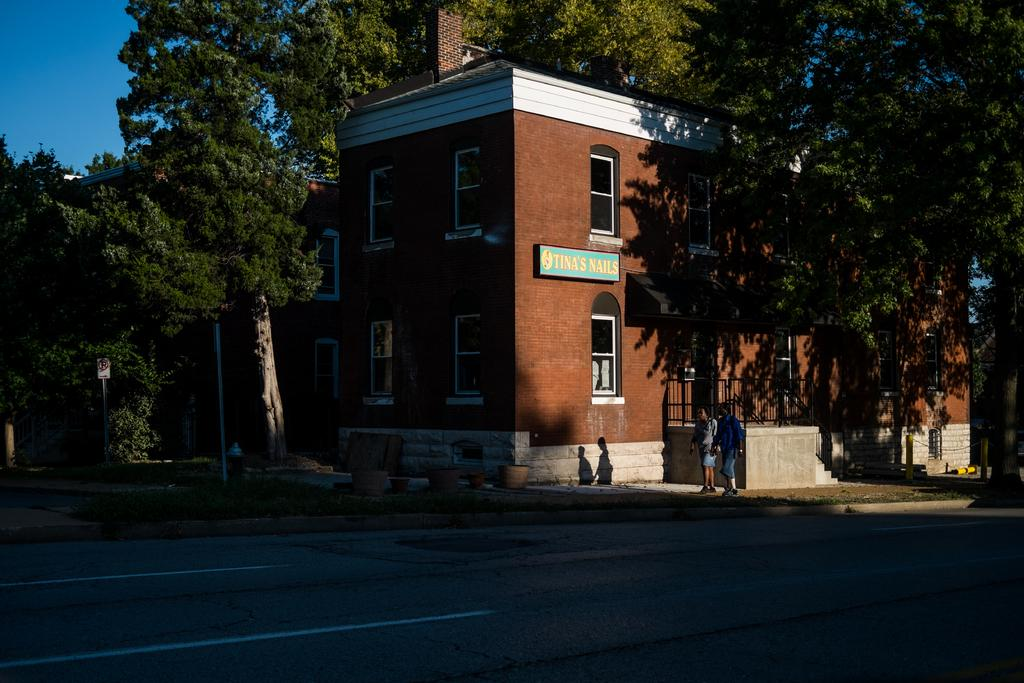What can be seen in the middle of the picture? There are trees, a building, people, plants, and other objects in the middle of the picture. Can you describe the building in the picture? The building is located in the middle of the picture. What is visible in the top left corner of the picture? The sky is visible at the top left corner of the picture. What is present at the bottom of the picture? White lines and other objects are present at the bottom of the picture. Where is the cemetery located in the picture? There is no cemetery present in the picture. What type of joke can be seen being told by the people in the picture? There is no joke being told by the people in the picture; they are simply present in the image. 